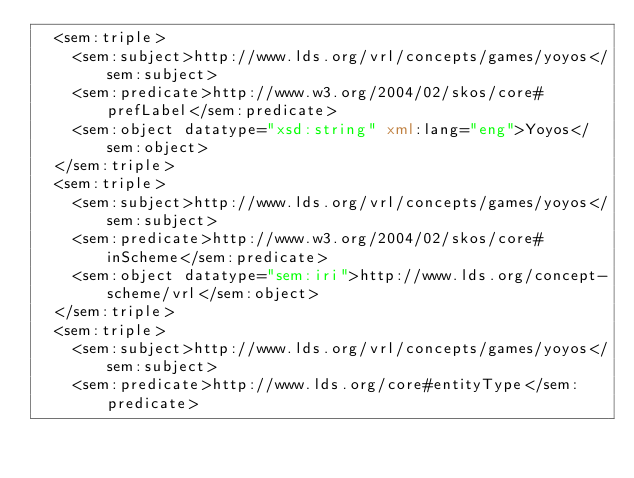<code> <loc_0><loc_0><loc_500><loc_500><_XML_>  <sem:triple>
    <sem:subject>http://www.lds.org/vrl/concepts/games/yoyos</sem:subject>
    <sem:predicate>http://www.w3.org/2004/02/skos/core#prefLabel</sem:predicate>
    <sem:object datatype="xsd:string" xml:lang="eng">Yoyos</sem:object>
  </sem:triple>
  <sem:triple>
    <sem:subject>http://www.lds.org/vrl/concepts/games/yoyos</sem:subject>
    <sem:predicate>http://www.w3.org/2004/02/skos/core#inScheme</sem:predicate>
    <sem:object datatype="sem:iri">http://www.lds.org/concept-scheme/vrl</sem:object>
  </sem:triple>
  <sem:triple>
    <sem:subject>http://www.lds.org/vrl/concepts/games/yoyos</sem:subject>
    <sem:predicate>http://www.lds.org/core#entityType</sem:predicate></code> 